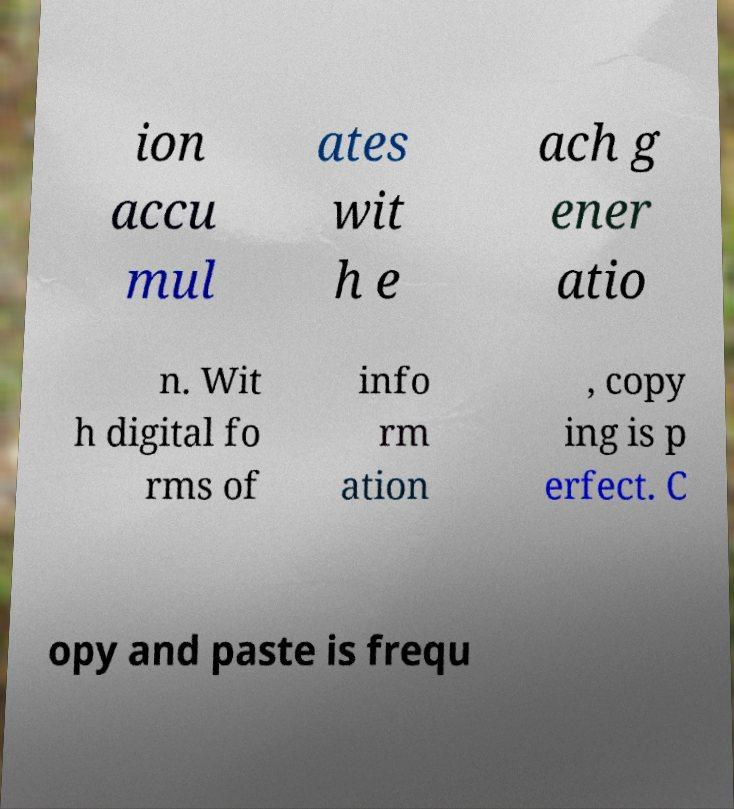Could you extract and type out the text from this image? ion accu mul ates wit h e ach g ener atio n. Wit h digital fo rms of info rm ation , copy ing is p erfect. C opy and paste is frequ 